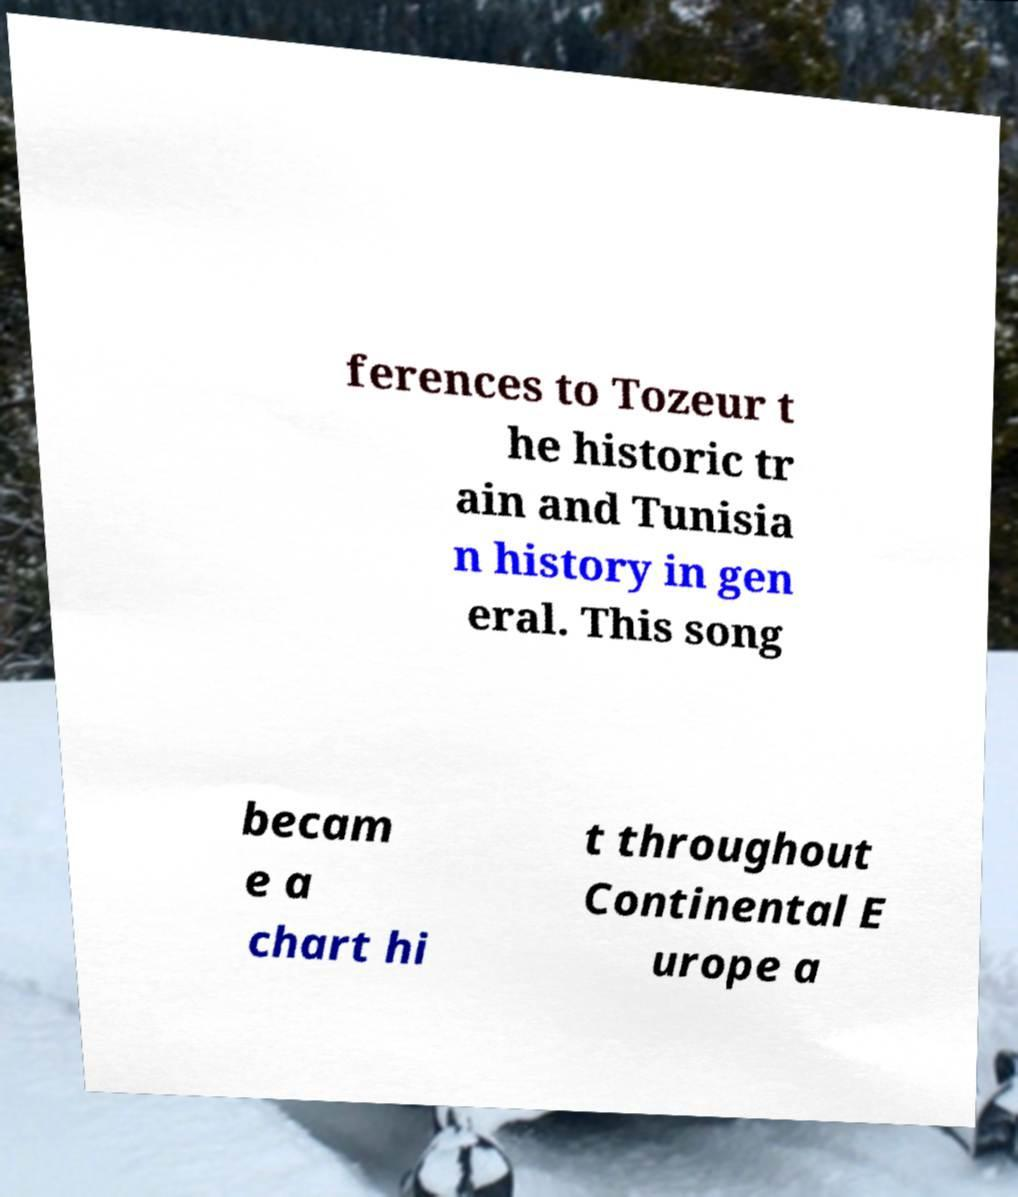Can you accurately transcribe the text from the provided image for me? ferences to Tozeur t he historic tr ain and Tunisia n history in gen eral. This song becam e a chart hi t throughout Continental E urope a 